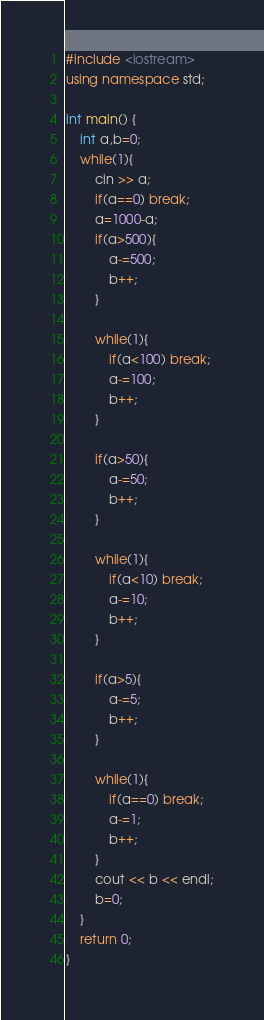Convert code to text. <code><loc_0><loc_0><loc_500><loc_500><_C++_>#include <iostream>
using namespace std;

int main() {
	int a,b=0;
	while(1){
		cin >> a;
		if(a==0) break;
		a=1000-a;
		if(a>500){
			a-=500;
			b++;
		}
	
		while(1){
			if(a<100) break;
			a-=100;
			b++;
		}

		if(a>50){
			a-=50;
			b++;
		}
	
		while(1){
			if(a<10) break;
			a-=10;
			b++;
		}
		
		if(a>5){
			a-=5;
			b++;
		}
		
		while(1){
			if(a==0) break;
			a-=1;
			b++;
		}
		cout << b << endl;
		b=0;
	}
	return 0;
}</code> 